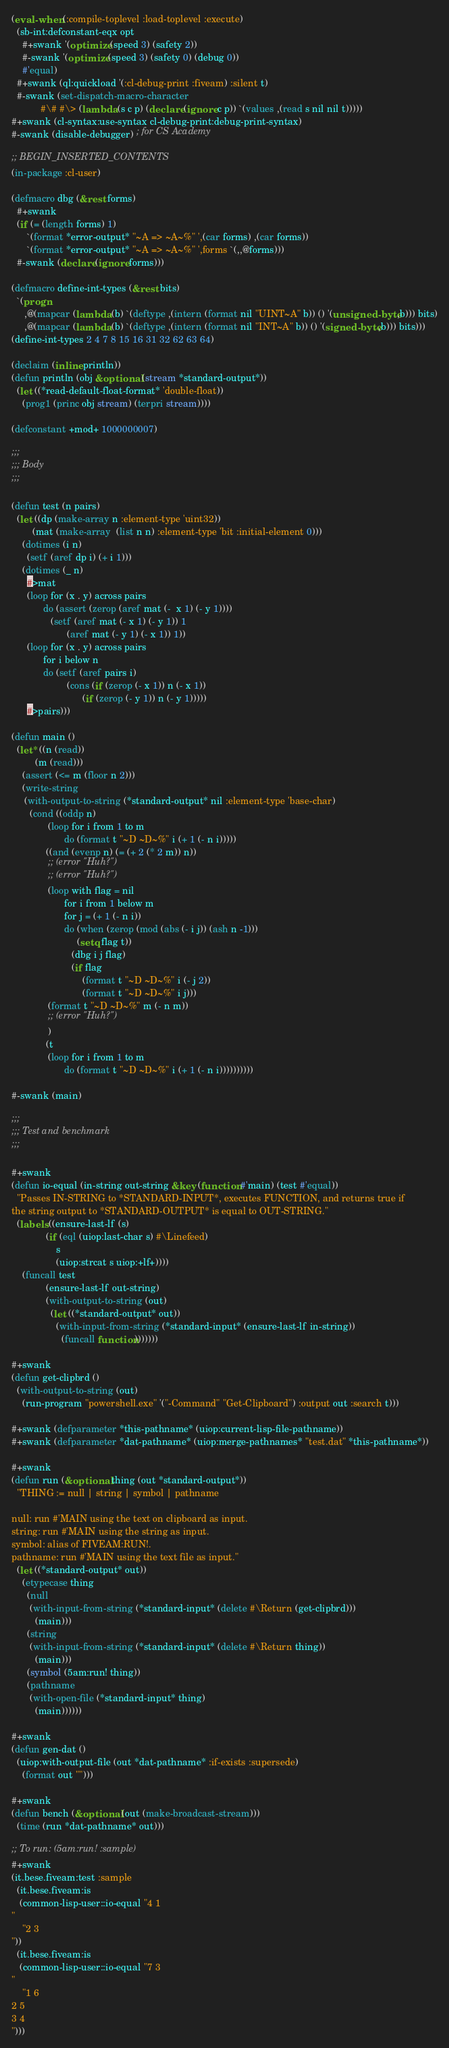Convert code to text. <code><loc_0><loc_0><loc_500><loc_500><_Lisp_>(eval-when (:compile-toplevel :load-toplevel :execute)
  (sb-int:defconstant-eqx opt
    #+swank '(optimize (speed 3) (safety 2))
    #-swank '(optimize (speed 3) (safety 0) (debug 0))
    #'equal)
  #+swank (ql:quickload '(:cl-debug-print :fiveam) :silent t)
  #-swank (set-dispatch-macro-character
           #\# #\> (lambda (s c p) (declare (ignore c p)) `(values ,(read s nil nil t)))))
#+swank (cl-syntax:use-syntax cl-debug-print:debug-print-syntax)
#-swank (disable-debugger) ; for CS Academy

;; BEGIN_INSERTED_CONTENTS
(in-package :cl-user)

(defmacro dbg (&rest forms)
  #+swank
  (if (= (length forms) 1)
      `(format *error-output* "~A => ~A~%" ',(car forms) ,(car forms))
      `(format *error-output* "~A => ~A~%" ',forms `(,,@forms)))
  #-swank (declare (ignore forms)))

(defmacro define-int-types (&rest bits)
  `(progn
     ,@(mapcar (lambda (b) `(deftype ,(intern (format nil "UINT~A" b)) () '(unsigned-byte ,b))) bits)
     ,@(mapcar (lambda (b) `(deftype ,(intern (format nil "INT~A" b)) () '(signed-byte ,b))) bits)))
(define-int-types 2 4 7 8 15 16 31 32 62 63 64)

(declaim (inline println))
(defun println (obj &optional (stream *standard-output*))
  (let ((*read-default-float-format* 'double-float))
    (prog1 (princ obj stream) (terpri stream))))

(defconstant +mod+ 1000000007)

;;;
;;; Body
;;;

(defun test (n pairs)
  (let ((dp (make-array n :element-type 'uint32))
        (mat (make-array  (list n n) :element-type 'bit :initial-element 0)))
    (dotimes (i n)
      (setf (aref dp i) (+ i 1)))
    (dotimes (_ n)
      #>mat
      (loop for (x . y) across pairs
            do (assert (zerop (aref mat (-  x 1) (- y 1))))
               (setf (aref mat (- x 1) (- y 1)) 1
                     (aref mat (- y 1) (- x 1)) 1))
      (loop for (x . y) across pairs
            for i below n
            do (setf (aref pairs i)
                     (cons (if (zerop (- x 1)) n (- x 1))
                           (if (zerop (- y 1)) n (- y 1)))))
      #>pairs)))

(defun main ()
  (let* ((n (read))
         (m (read)))
    (assert (<= m (floor n 2)))
    (write-string
     (with-output-to-string (*standard-output* nil :element-type 'base-char)
       (cond ((oddp n)
              (loop for i from 1 to m
                    do (format t "~D ~D~%" i (+ 1 (- n i)))))
             ((and (evenp n) (= (+ 2 (* 2 m)) n))
              ;; (error "Huh?")
              ;; (error "Huh?")
              (loop with flag = nil
                    for i from 1 below m
                    for j = (+ 1 (- n i))
                    do (when (zerop (mod (abs (- i j)) (ash n -1)))
                         (setq flag t))
                       (dbg i j flag)
                       (if flag
                           (format t "~D ~D~%" i (- j 2))
                           (format t "~D ~D~%" i j)))
              (format t "~D ~D~%" m (- n m))
              ;; (error "Huh?")
              )
             (t
              (loop for i from 1 to m
                    do (format t "~D ~D~%" i (+ 1 (- n i))))))))))

#-swank (main)

;;;
;;; Test and benchmark
;;;

#+swank
(defun io-equal (in-string out-string &key (function #'main) (test #'equal))
  "Passes IN-STRING to *STANDARD-INPUT*, executes FUNCTION, and returns true if
the string output to *STANDARD-OUTPUT* is equal to OUT-STRING."
  (labels ((ensure-last-lf (s)
             (if (eql (uiop:last-char s) #\Linefeed)
                 s
                 (uiop:strcat s uiop:+lf+))))
    (funcall test
             (ensure-last-lf out-string)
             (with-output-to-string (out)
               (let ((*standard-output* out))
                 (with-input-from-string (*standard-input* (ensure-last-lf in-string))
                   (funcall function)))))))

#+swank
(defun get-clipbrd ()
  (with-output-to-string (out)
    (run-program "powershell.exe" '("-Command" "Get-Clipboard") :output out :search t)))

#+swank (defparameter *this-pathname* (uiop:current-lisp-file-pathname))
#+swank (defparameter *dat-pathname* (uiop:merge-pathnames* "test.dat" *this-pathname*))

#+swank
(defun run (&optional thing (out *standard-output*))
  "THING := null | string | symbol | pathname

null: run #'MAIN using the text on clipboard as input.
string: run #'MAIN using the string as input.
symbol: alias of FIVEAM:RUN!.
pathname: run #'MAIN using the text file as input."
  (let ((*standard-output* out))
    (etypecase thing
      (null
       (with-input-from-string (*standard-input* (delete #\Return (get-clipbrd)))
         (main)))
      (string
       (with-input-from-string (*standard-input* (delete #\Return thing))
         (main)))
      (symbol (5am:run! thing))
      (pathname
       (with-open-file (*standard-input* thing)
         (main))))))

#+swank
(defun gen-dat ()
  (uiop:with-output-file (out *dat-pathname* :if-exists :supersede)
    (format out "")))

#+swank
(defun bench (&optional (out (make-broadcast-stream)))
  (time (run *dat-pathname* out)))

;; To run: (5am:run! :sample)
#+swank
(it.bese.fiveam:test :sample
  (it.bese.fiveam:is
   (common-lisp-user::io-equal "4 1
"
    "2 3
"))
  (it.bese.fiveam:is
   (common-lisp-user::io-equal "7 3
"
    "1 6
2 5
3 4
")))
</code> 